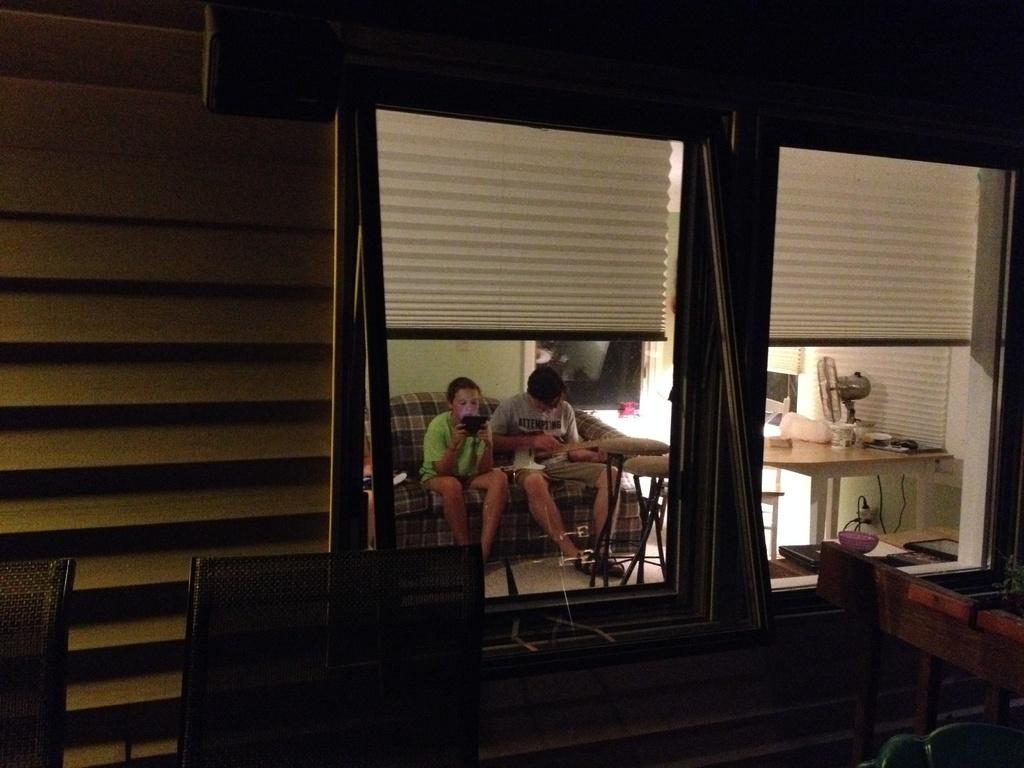How many people are in the image? There are two persons in the image. What are the two persons doing in the image? The two persons are sitting on a sofa. Can you describe any objects visible in the image? Yes, there is a table fan on the right side of the image. What type of trade is being conducted between the two persons in the image? There is no indication of any trade being conducted between the two persons in the image. What color is the ink used to write on the sofa? There is no ink or writing visible on the sofa in the image. 